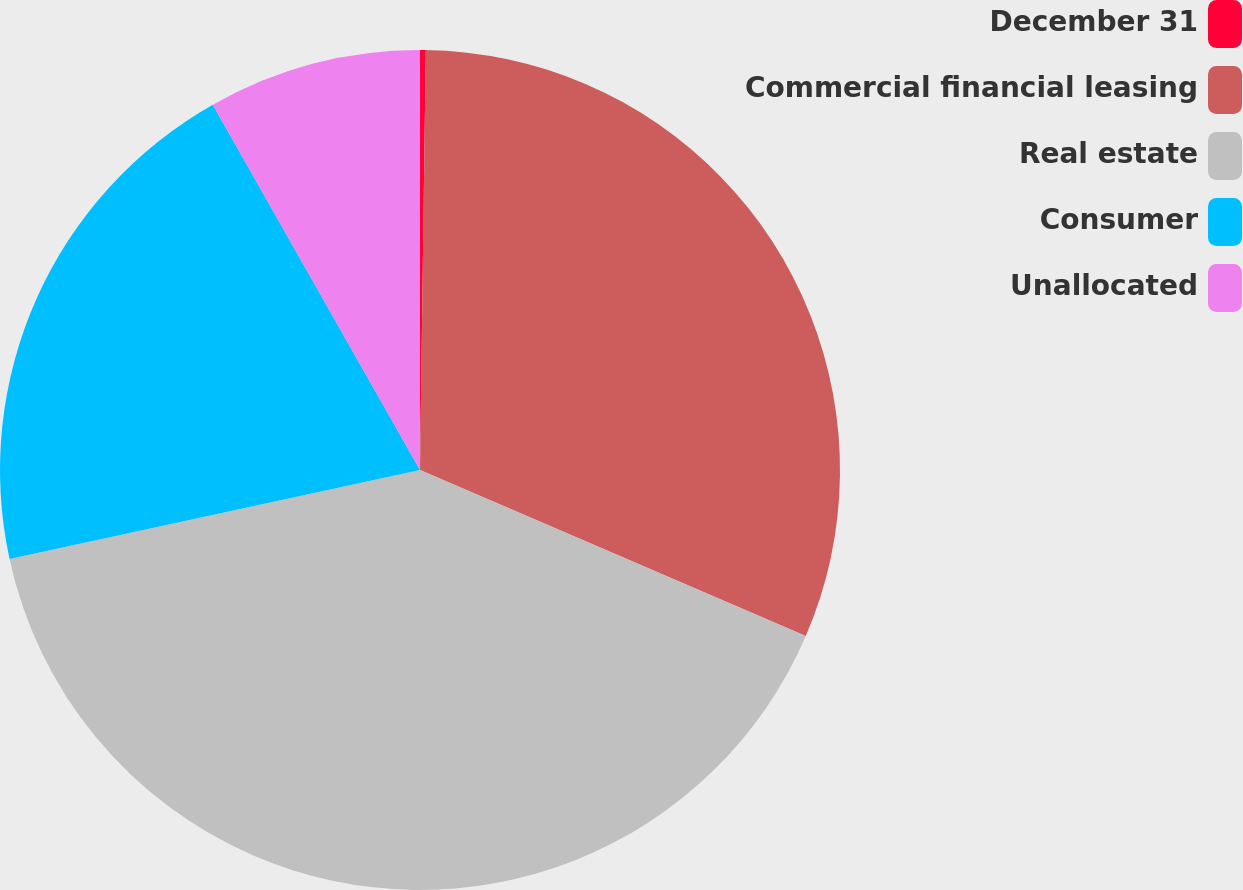Convert chart. <chart><loc_0><loc_0><loc_500><loc_500><pie_chart><fcel>December 31<fcel>Commercial financial leasing<fcel>Real estate<fcel>Consumer<fcel>Unallocated<nl><fcel>0.22%<fcel>31.25%<fcel>40.13%<fcel>20.19%<fcel>8.21%<nl></chart> 